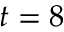Convert formula to latex. <formula><loc_0><loc_0><loc_500><loc_500>t = 8</formula> 